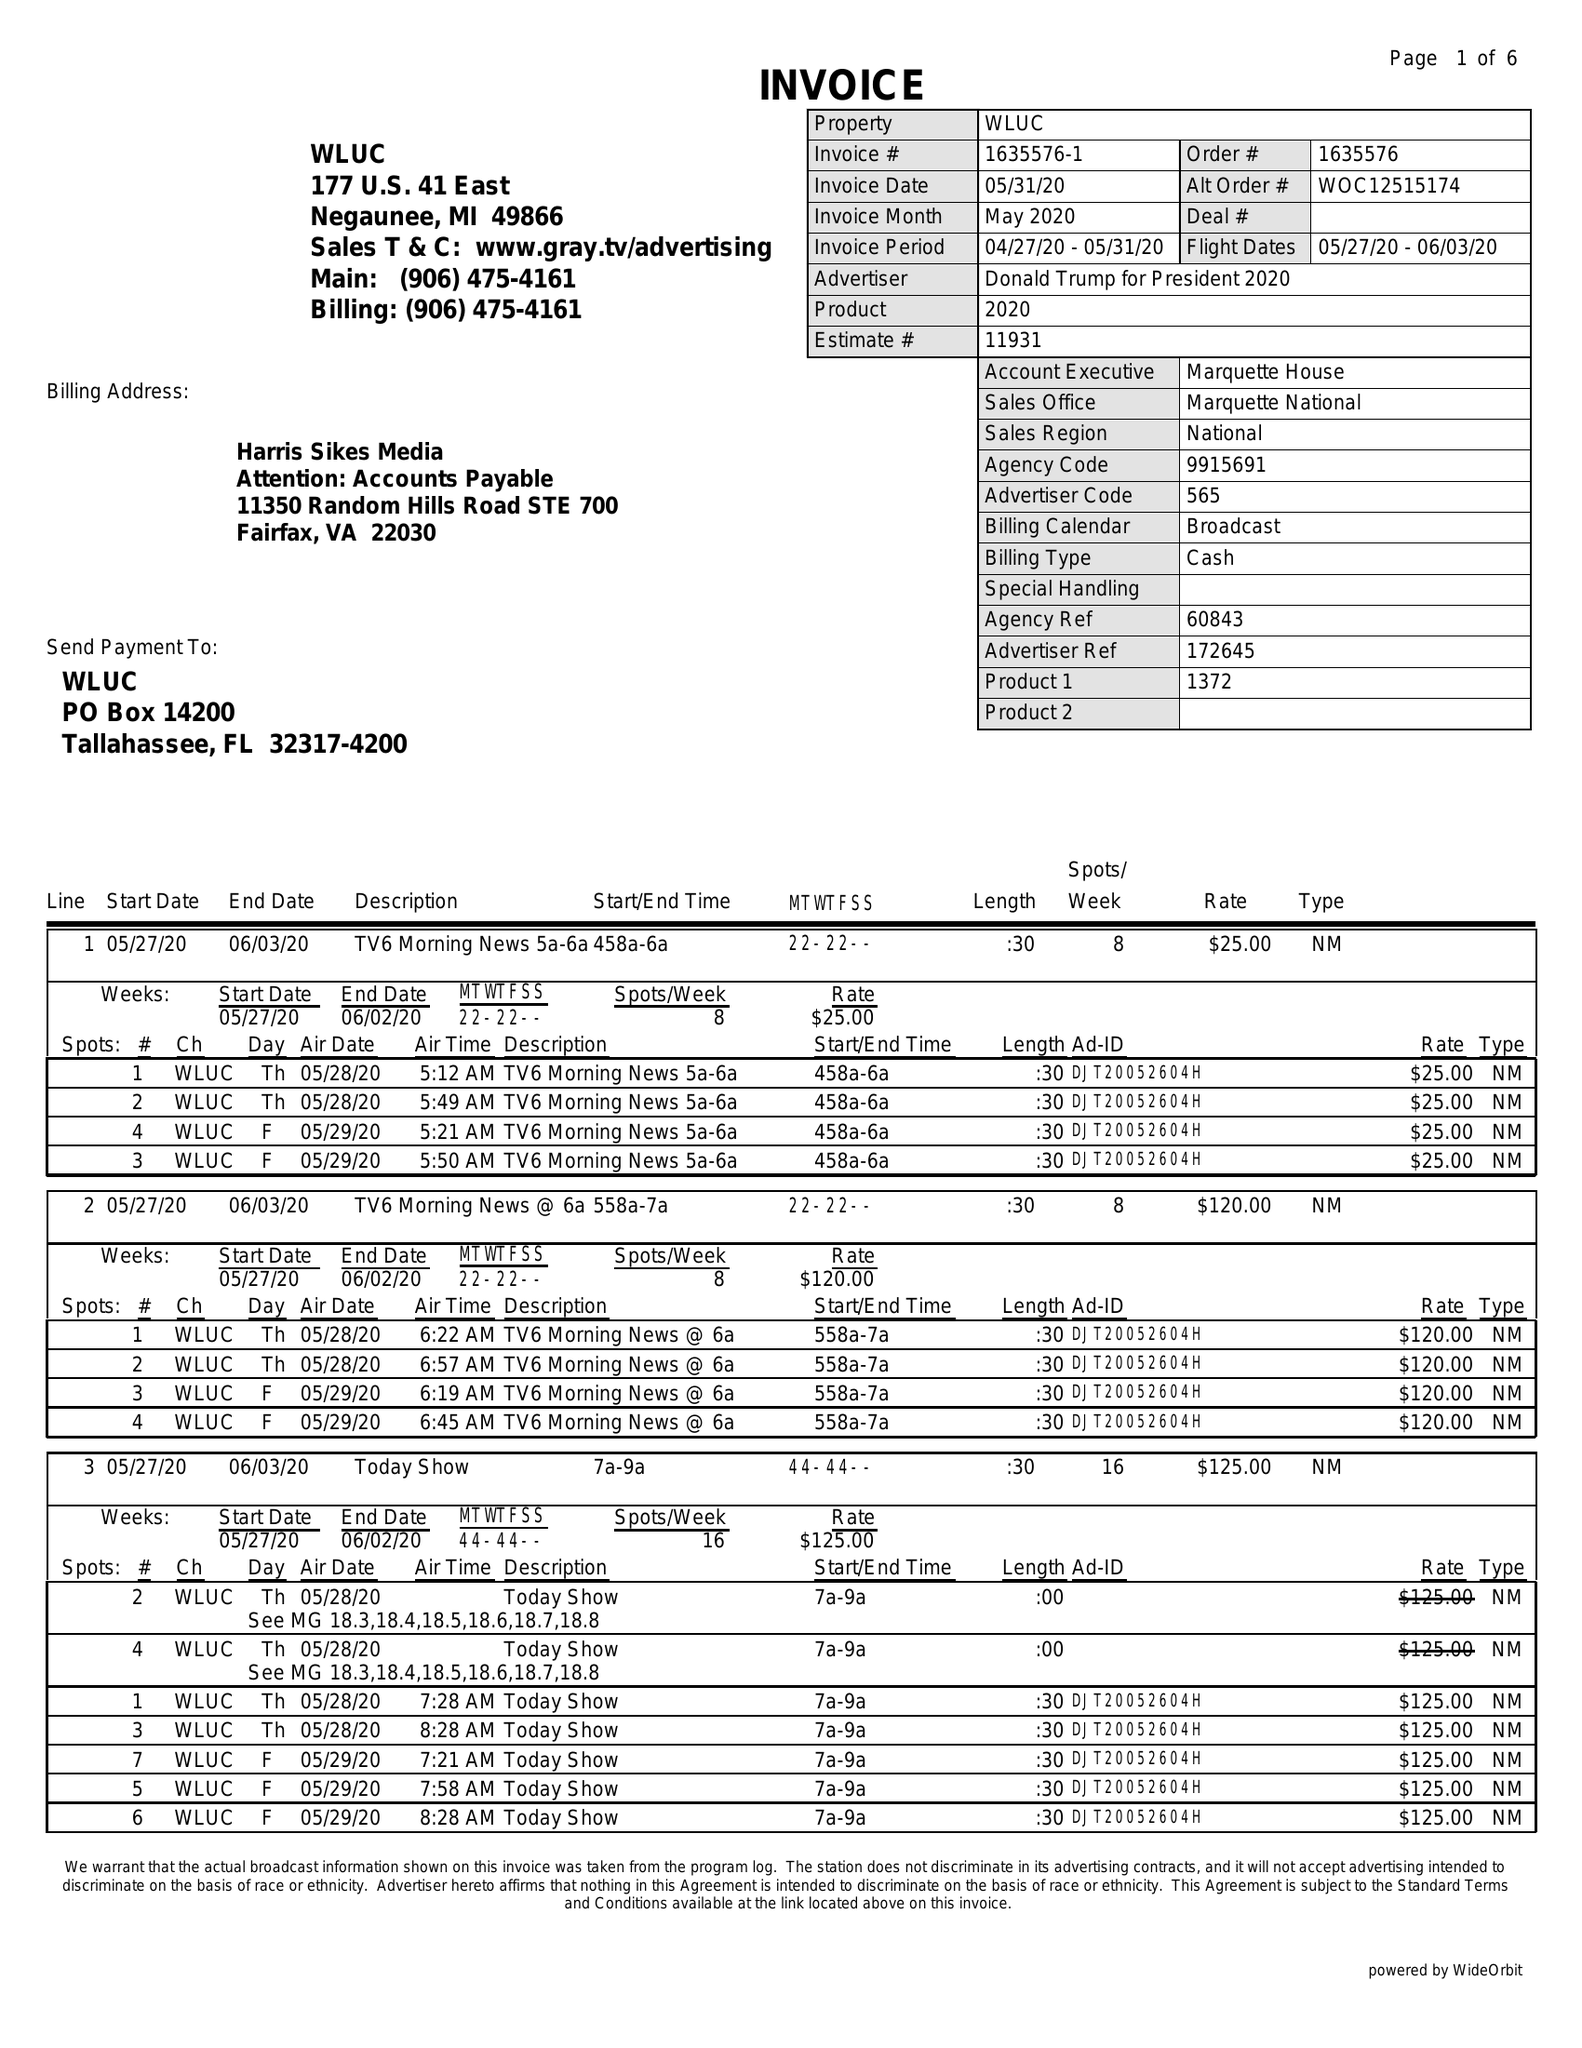What is the value for the gross_amount?
Answer the question using a single word or phrase. 6355.00 